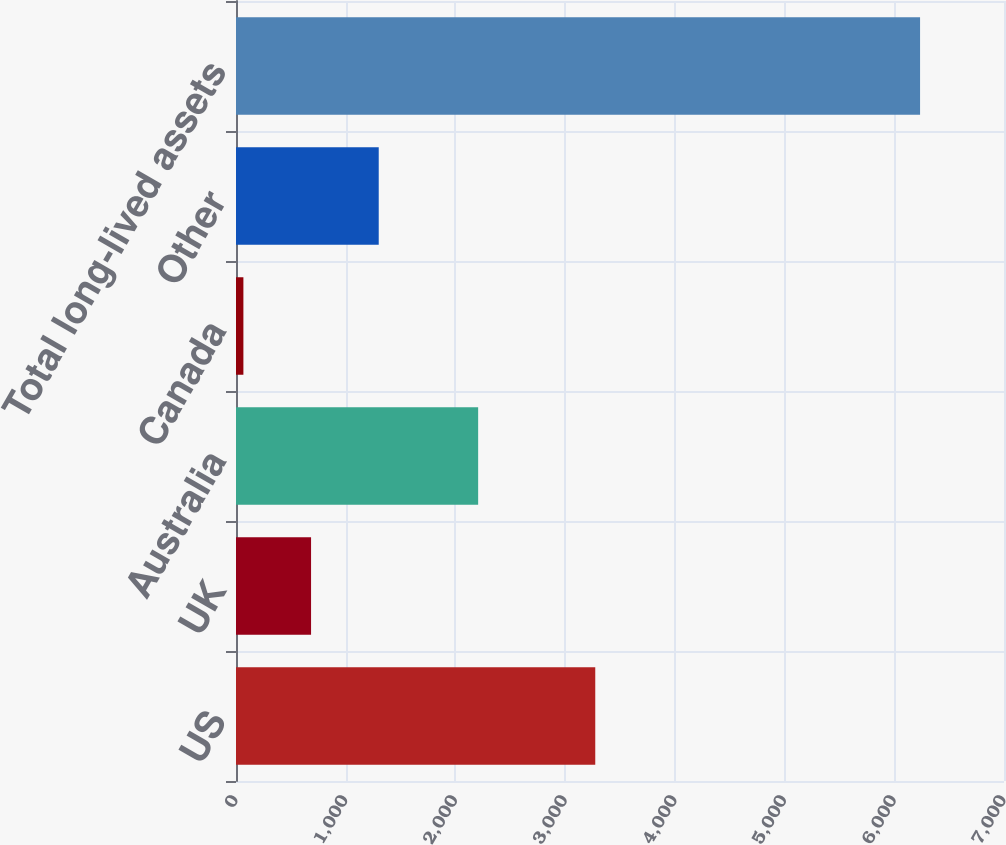<chart> <loc_0><loc_0><loc_500><loc_500><bar_chart><fcel>US<fcel>UK<fcel>Australia<fcel>Canada<fcel>Other<fcel>Total long-lived assets<nl><fcel>3274.5<fcel>684.16<fcel>2207.1<fcel>67.4<fcel>1300.92<fcel>6235<nl></chart> 